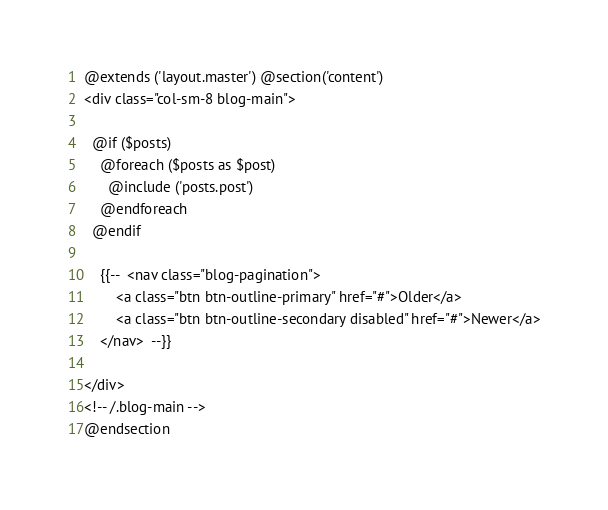Convert code to text. <code><loc_0><loc_0><loc_500><loc_500><_PHP_>@extends ('layout.master') @section('content')
<div class="col-sm-8 blog-main">

  @if ($posts)
    @foreach ($posts as $post)
      @include ('posts.post')
    @endforeach
  @endif

	{{--  <nav class="blog-pagination">
		<a class="btn btn-outline-primary" href="#">Older</a>
		<a class="btn btn-outline-secondary disabled" href="#">Newer</a>
	</nav>  --}}

</div>
<!-- /.blog-main -->
@endsection
</code> 